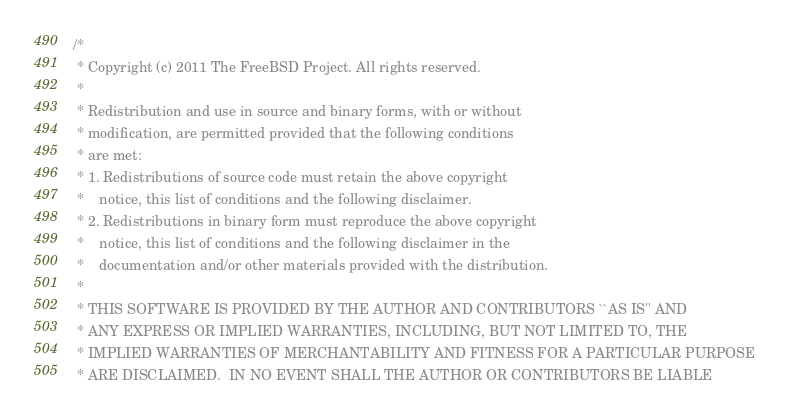Convert code to text. <code><loc_0><loc_0><loc_500><loc_500><_C_>/*
 * Copyright (c) 2011 The FreeBSD Project. All rights reserved.
 *
 * Redistribution and use in source and binary forms, with or without
 * modification, are permitted provided that the following conditions
 * are met:
 * 1. Redistributions of source code must retain the above copyright
 *    notice, this list of conditions and the following disclaimer.
 * 2. Redistributions in binary form must reproduce the above copyright
 *    notice, this list of conditions and the following disclaimer in the
 *    documentation and/or other materials provided with the distribution.
 *
 * THIS SOFTWARE IS PROVIDED BY THE AUTHOR AND CONTRIBUTORS ``AS IS'' AND
 * ANY EXPRESS OR IMPLIED WARRANTIES, INCLUDING, BUT NOT LIMITED TO, THE
 * IMPLIED WARRANTIES OF MERCHANTABILITY AND FITNESS FOR A PARTICULAR PURPOSE
 * ARE DISCLAIMED.  IN NO EVENT SHALL THE AUTHOR OR CONTRIBUTORS BE LIABLE</code> 